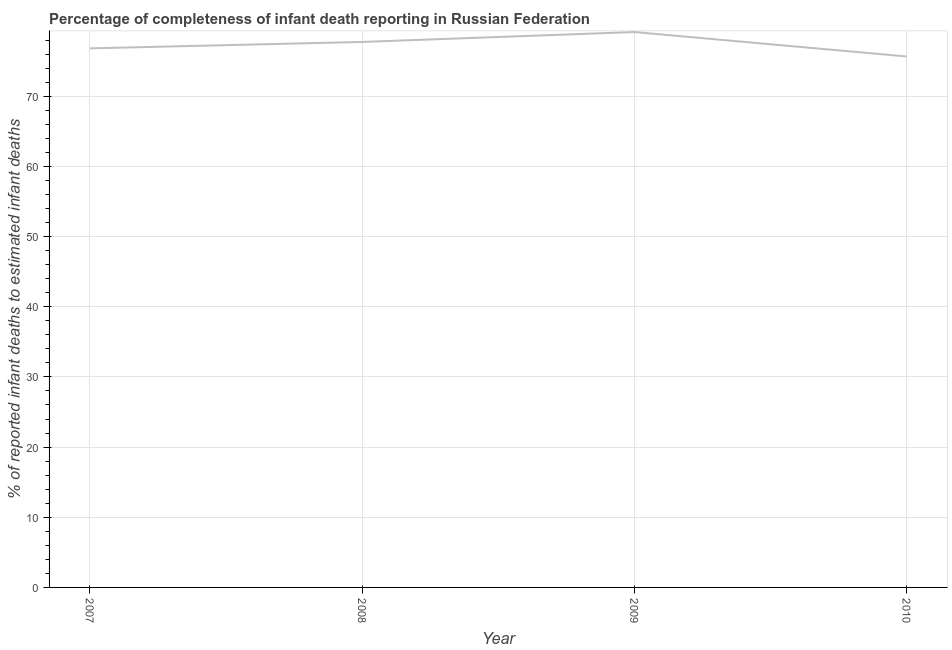What is the completeness of infant death reporting in 2007?
Offer a terse response. 76.82. Across all years, what is the maximum completeness of infant death reporting?
Make the answer very short. 79.14. Across all years, what is the minimum completeness of infant death reporting?
Your response must be concise. 75.66. In which year was the completeness of infant death reporting minimum?
Provide a succinct answer. 2010. What is the sum of the completeness of infant death reporting?
Your response must be concise. 309.36. What is the difference between the completeness of infant death reporting in 2007 and 2008?
Offer a very short reply. -0.92. What is the average completeness of infant death reporting per year?
Your answer should be very brief. 77.34. What is the median completeness of infant death reporting?
Your answer should be very brief. 77.28. Do a majority of the years between 2009 and 2010 (inclusive) have completeness of infant death reporting greater than 30 %?
Ensure brevity in your answer.  Yes. What is the ratio of the completeness of infant death reporting in 2009 to that in 2010?
Your answer should be very brief. 1.05. Is the completeness of infant death reporting in 2007 less than that in 2008?
Offer a terse response. Yes. Is the difference between the completeness of infant death reporting in 2008 and 2009 greater than the difference between any two years?
Make the answer very short. No. What is the difference between the highest and the second highest completeness of infant death reporting?
Provide a short and direct response. 1.41. Is the sum of the completeness of infant death reporting in 2007 and 2008 greater than the maximum completeness of infant death reporting across all years?
Provide a short and direct response. Yes. What is the difference between the highest and the lowest completeness of infant death reporting?
Give a very brief answer. 3.48. Does the completeness of infant death reporting monotonically increase over the years?
Provide a succinct answer. No. How many lines are there?
Your answer should be very brief. 1. Are the values on the major ticks of Y-axis written in scientific E-notation?
Provide a short and direct response. No. Does the graph contain grids?
Give a very brief answer. Yes. What is the title of the graph?
Ensure brevity in your answer.  Percentage of completeness of infant death reporting in Russian Federation. What is the label or title of the X-axis?
Offer a very short reply. Year. What is the label or title of the Y-axis?
Provide a short and direct response. % of reported infant deaths to estimated infant deaths. What is the % of reported infant deaths to estimated infant deaths of 2007?
Your answer should be very brief. 76.82. What is the % of reported infant deaths to estimated infant deaths in 2008?
Keep it short and to the point. 77.73. What is the % of reported infant deaths to estimated infant deaths in 2009?
Offer a terse response. 79.14. What is the % of reported infant deaths to estimated infant deaths of 2010?
Ensure brevity in your answer.  75.66. What is the difference between the % of reported infant deaths to estimated infant deaths in 2007 and 2008?
Your response must be concise. -0.92. What is the difference between the % of reported infant deaths to estimated infant deaths in 2007 and 2009?
Keep it short and to the point. -2.33. What is the difference between the % of reported infant deaths to estimated infant deaths in 2007 and 2010?
Offer a very short reply. 1.16. What is the difference between the % of reported infant deaths to estimated infant deaths in 2008 and 2009?
Provide a short and direct response. -1.41. What is the difference between the % of reported infant deaths to estimated infant deaths in 2008 and 2010?
Provide a succinct answer. 2.07. What is the difference between the % of reported infant deaths to estimated infant deaths in 2009 and 2010?
Your answer should be compact. 3.48. What is the ratio of the % of reported infant deaths to estimated infant deaths in 2007 to that in 2008?
Your answer should be very brief. 0.99. What is the ratio of the % of reported infant deaths to estimated infant deaths in 2007 to that in 2009?
Give a very brief answer. 0.97. What is the ratio of the % of reported infant deaths to estimated infant deaths in 2007 to that in 2010?
Make the answer very short. 1.01. What is the ratio of the % of reported infant deaths to estimated infant deaths in 2008 to that in 2009?
Your answer should be very brief. 0.98. What is the ratio of the % of reported infant deaths to estimated infant deaths in 2008 to that in 2010?
Your response must be concise. 1.03. What is the ratio of the % of reported infant deaths to estimated infant deaths in 2009 to that in 2010?
Give a very brief answer. 1.05. 